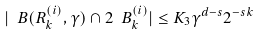<formula> <loc_0><loc_0><loc_500><loc_500>| \ B ( R _ { k } ^ { ( i ) } , \gamma ) \cap 2 \ B _ { k } ^ { ( i ) } | \leq K _ { 3 } \gamma ^ { d - s } 2 ^ { - s k }</formula> 